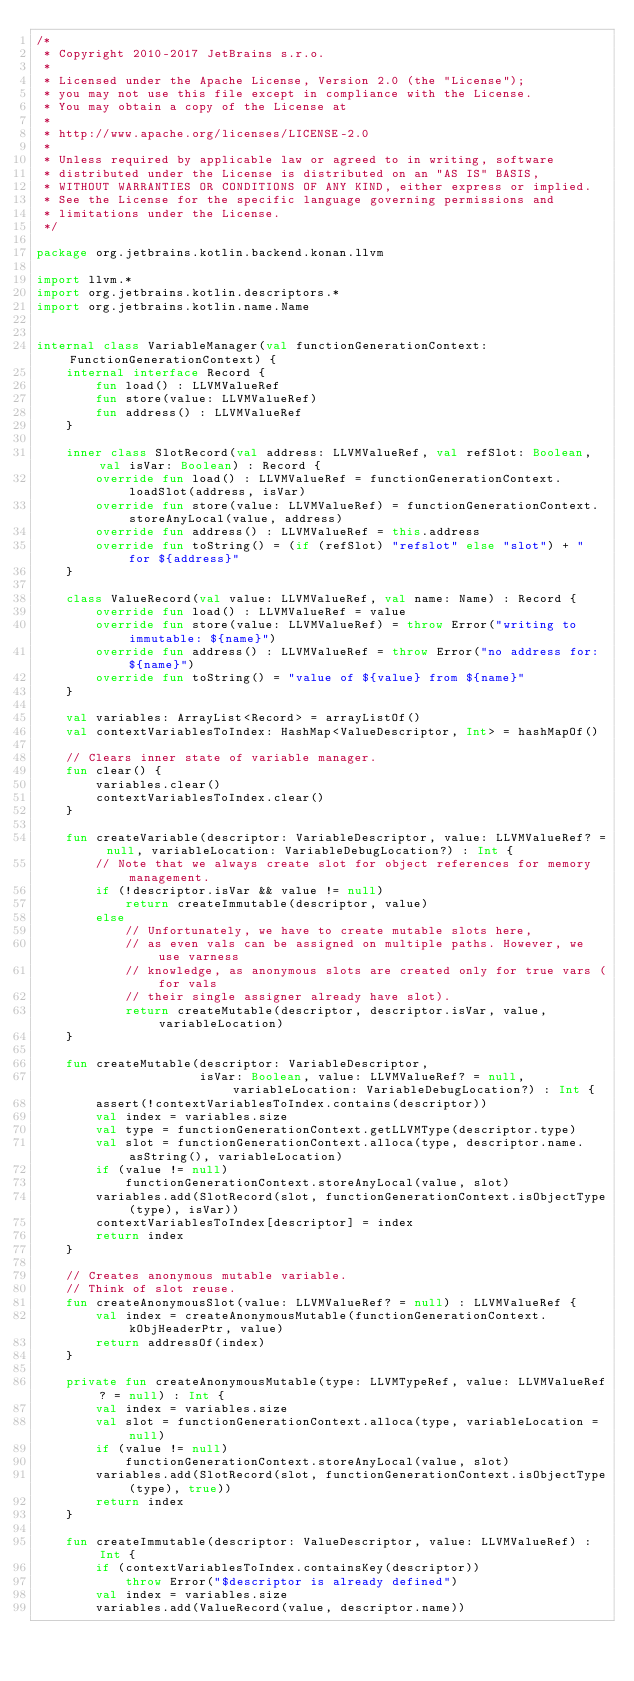Convert code to text. <code><loc_0><loc_0><loc_500><loc_500><_Kotlin_>/*
 * Copyright 2010-2017 JetBrains s.r.o.
 *
 * Licensed under the Apache License, Version 2.0 (the "License");
 * you may not use this file except in compliance with the License.
 * You may obtain a copy of the License at
 *
 * http://www.apache.org/licenses/LICENSE-2.0
 *
 * Unless required by applicable law or agreed to in writing, software
 * distributed under the License is distributed on an "AS IS" BASIS,
 * WITHOUT WARRANTIES OR CONDITIONS OF ANY KIND, either express or implied.
 * See the License for the specific language governing permissions and
 * limitations under the License.
 */

package org.jetbrains.kotlin.backend.konan.llvm

import llvm.*
import org.jetbrains.kotlin.descriptors.*
import org.jetbrains.kotlin.name.Name


internal class VariableManager(val functionGenerationContext: FunctionGenerationContext) {
    internal interface Record {
        fun load() : LLVMValueRef
        fun store(value: LLVMValueRef)
        fun address() : LLVMValueRef
    }

    inner class SlotRecord(val address: LLVMValueRef, val refSlot: Boolean, val isVar: Boolean) : Record {
        override fun load() : LLVMValueRef = functionGenerationContext.loadSlot(address, isVar)
        override fun store(value: LLVMValueRef) = functionGenerationContext.storeAnyLocal(value, address)
        override fun address() : LLVMValueRef = this.address
        override fun toString() = (if (refSlot) "refslot" else "slot") + " for ${address}"
    }

    class ValueRecord(val value: LLVMValueRef, val name: Name) : Record {
        override fun load() : LLVMValueRef = value
        override fun store(value: LLVMValueRef) = throw Error("writing to immutable: ${name}")
        override fun address() : LLVMValueRef = throw Error("no address for: ${name}")
        override fun toString() = "value of ${value} from ${name}"
    }

    val variables: ArrayList<Record> = arrayListOf()
    val contextVariablesToIndex: HashMap<ValueDescriptor, Int> = hashMapOf()

    // Clears inner state of variable manager.
    fun clear() {
        variables.clear()
        contextVariablesToIndex.clear()
    }

    fun createVariable(descriptor: VariableDescriptor, value: LLVMValueRef? = null, variableLocation: VariableDebugLocation?) : Int {
        // Note that we always create slot for object references for memory management.
        if (!descriptor.isVar && value != null)
            return createImmutable(descriptor, value)
        else
            // Unfortunately, we have to create mutable slots here,
            // as even vals can be assigned on multiple paths. However, we use varness
            // knowledge, as anonymous slots are created only for true vars (for vals
            // their single assigner already have slot).
            return createMutable(descriptor, descriptor.isVar, value, variableLocation)
    }

    fun createMutable(descriptor: VariableDescriptor,
                      isVar: Boolean, value: LLVMValueRef? = null, variableLocation: VariableDebugLocation?) : Int {
        assert(!contextVariablesToIndex.contains(descriptor))
        val index = variables.size
        val type = functionGenerationContext.getLLVMType(descriptor.type)
        val slot = functionGenerationContext.alloca(type, descriptor.name.asString(), variableLocation)
        if (value != null)
            functionGenerationContext.storeAnyLocal(value, slot)
        variables.add(SlotRecord(slot, functionGenerationContext.isObjectType(type), isVar))
        contextVariablesToIndex[descriptor] = index
        return index
    }

    // Creates anonymous mutable variable.
    // Think of slot reuse.
    fun createAnonymousSlot(value: LLVMValueRef? = null) : LLVMValueRef {
        val index = createAnonymousMutable(functionGenerationContext.kObjHeaderPtr, value)
        return addressOf(index)
    }

    private fun createAnonymousMutable(type: LLVMTypeRef, value: LLVMValueRef? = null) : Int {
        val index = variables.size
        val slot = functionGenerationContext.alloca(type, variableLocation = null)
        if (value != null)
            functionGenerationContext.storeAnyLocal(value, slot)
        variables.add(SlotRecord(slot, functionGenerationContext.isObjectType(type), true))
        return index
    }

    fun createImmutable(descriptor: ValueDescriptor, value: LLVMValueRef) : Int {
        if (contextVariablesToIndex.containsKey(descriptor))
            throw Error("$descriptor is already defined")
        val index = variables.size
        variables.add(ValueRecord(value, descriptor.name))</code> 